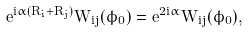Convert formula to latex. <formula><loc_0><loc_0><loc_500><loc_500>e ^ { i \alpha ( R _ { i } + R _ { j } ) } W _ { i j } ( \hat { \phi } _ { 0 } ) = e ^ { 2 i \alpha } W _ { i j } ( \hat { \phi } _ { 0 } ) ,</formula> 